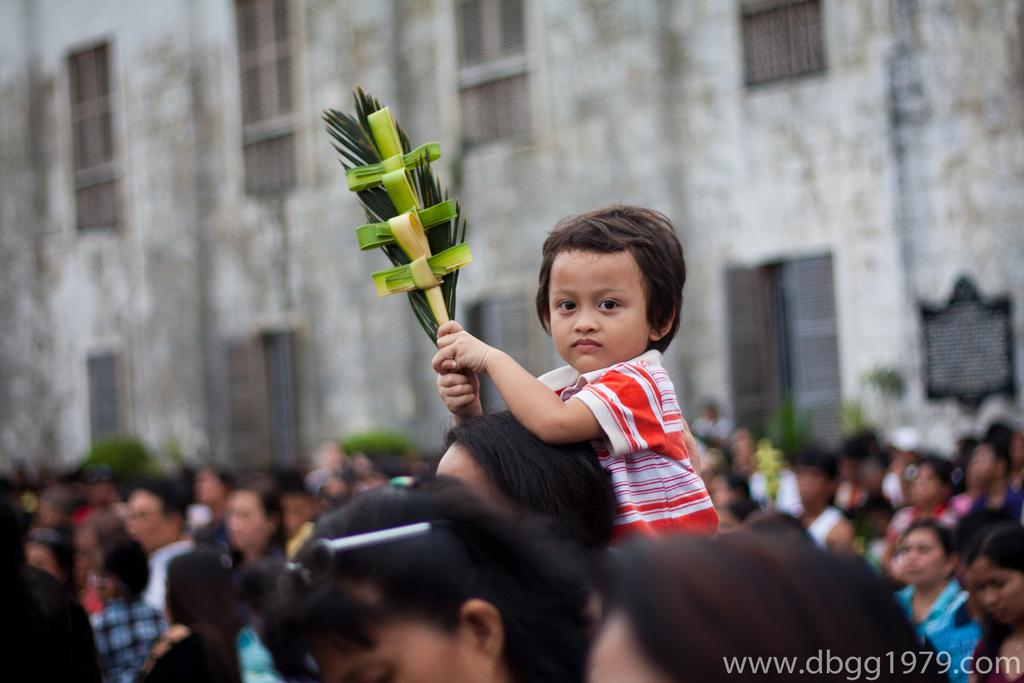How many people are in the group visible in the image? There is a group of people in the image, but the exact number cannot be determined due to the image being blurred in the background. What type of structures can be seen in the image? There are buildings in the image. What architectural feature is present in the buildings? There are windows in the buildings. What type of vegetation is present in the image? There are plants in the image. Can you see a mark on the goat in the image? There is no goat present in the image. How many pigs are visible in the image? There are no pigs present in the image. 